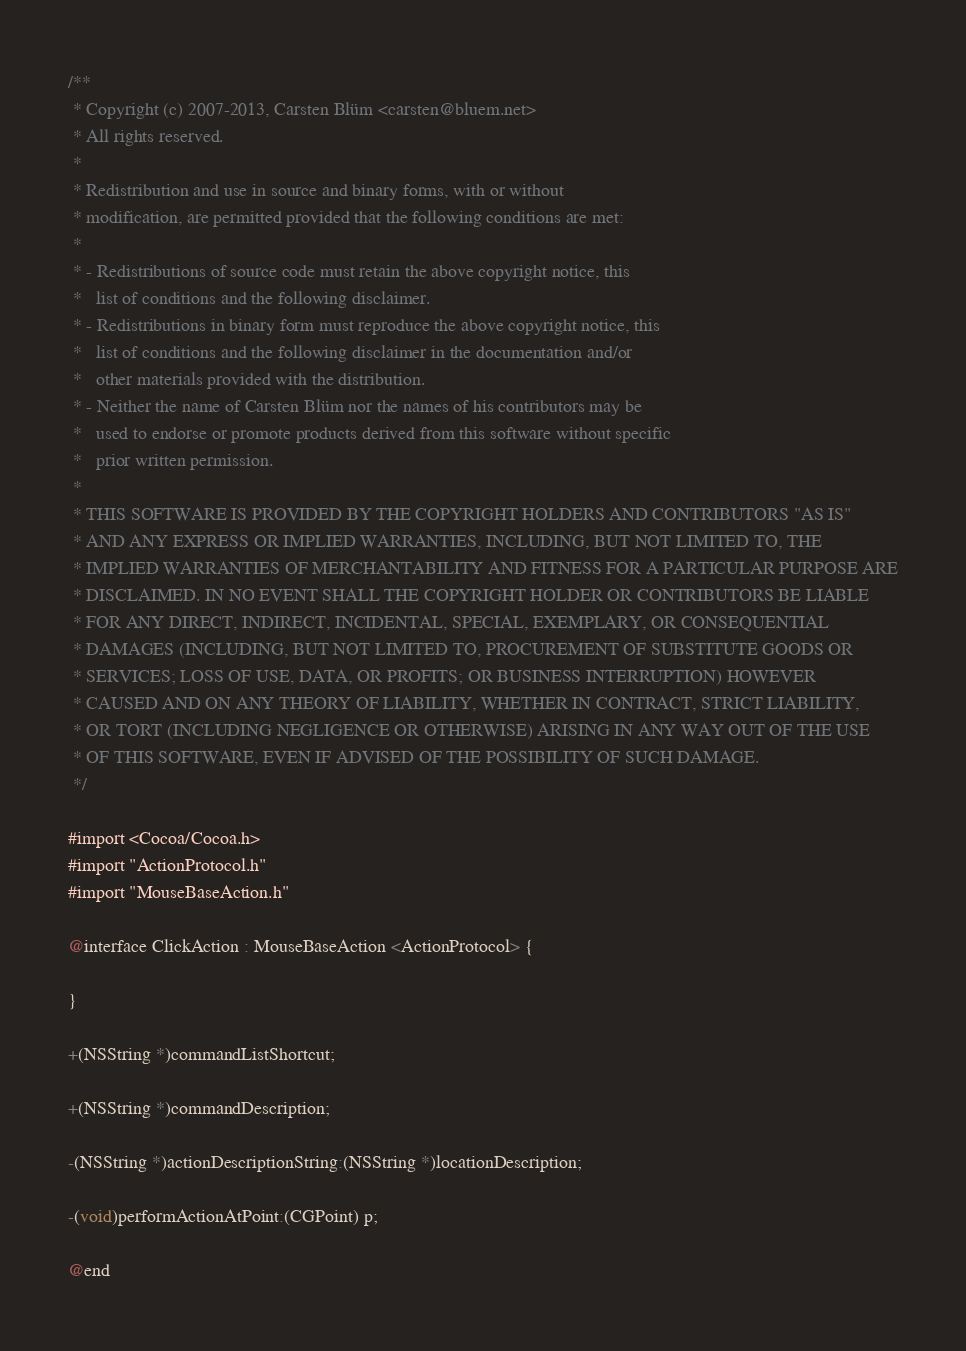Convert code to text. <code><loc_0><loc_0><loc_500><loc_500><_C_>/**
 * Copyright (c) 2007-2013, Carsten Blüm <carsten@bluem.net>
 * All rights reserved.
 *
 * Redistribution and use in source and binary forms, with or without
 * modification, are permitted provided that the following conditions are met:
 *
 * - Redistributions of source code must retain the above copyright notice, this
 *   list of conditions and the following disclaimer.
 * - Redistributions in binary form must reproduce the above copyright notice, this
 *   list of conditions and the following disclaimer in the documentation and/or
 *   other materials provided with the distribution.
 * - Neither the name of Carsten Blüm nor the names of his contributors may be
 *   used to endorse or promote products derived from this software without specific
 *   prior written permission.
 *
 * THIS SOFTWARE IS PROVIDED BY THE COPYRIGHT HOLDERS AND CONTRIBUTORS "AS IS"
 * AND ANY EXPRESS OR IMPLIED WARRANTIES, INCLUDING, BUT NOT LIMITED TO, THE
 * IMPLIED WARRANTIES OF MERCHANTABILITY AND FITNESS FOR A PARTICULAR PURPOSE ARE
 * DISCLAIMED. IN NO EVENT SHALL THE COPYRIGHT HOLDER OR CONTRIBUTORS BE LIABLE
 * FOR ANY DIRECT, INDIRECT, INCIDENTAL, SPECIAL, EXEMPLARY, OR CONSEQUENTIAL
 * DAMAGES (INCLUDING, BUT NOT LIMITED TO, PROCUREMENT OF SUBSTITUTE GOODS OR
 * SERVICES; LOSS OF USE, DATA, OR PROFITS; OR BUSINESS INTERRUPTION) HOWEVER
 * CAUSED AND ON ANY THEORY OF LIABILITY, WHETHER IN CONTRACT, STRICT LIABILITY,
 * OR TORT (INCLUDING NEGLIGENCE OR OTHERWISE) ARISING IN ANY WAY OUT OF THE USE
 * OF THIS SOFTWARE, EVEN IF ADVISED OF THE POSSIBILITY OF SUCH DAMAGE.
 */

#import <Cocoa/Cocoa.h>
#import "ActionProtocol.h"
#import "MouseBaseAction.h"

@interface ClickAction : MouseBaseAction <ActionProtocol> {

}

+(NSString *)commandListShortcut;

+(NSString *)commandDescription;

-(NSString *)actionDescriptionString:(NSString *)locationDescription;

-(void)performActionAtPoint:(CGPoint) p;

@end
</code> 